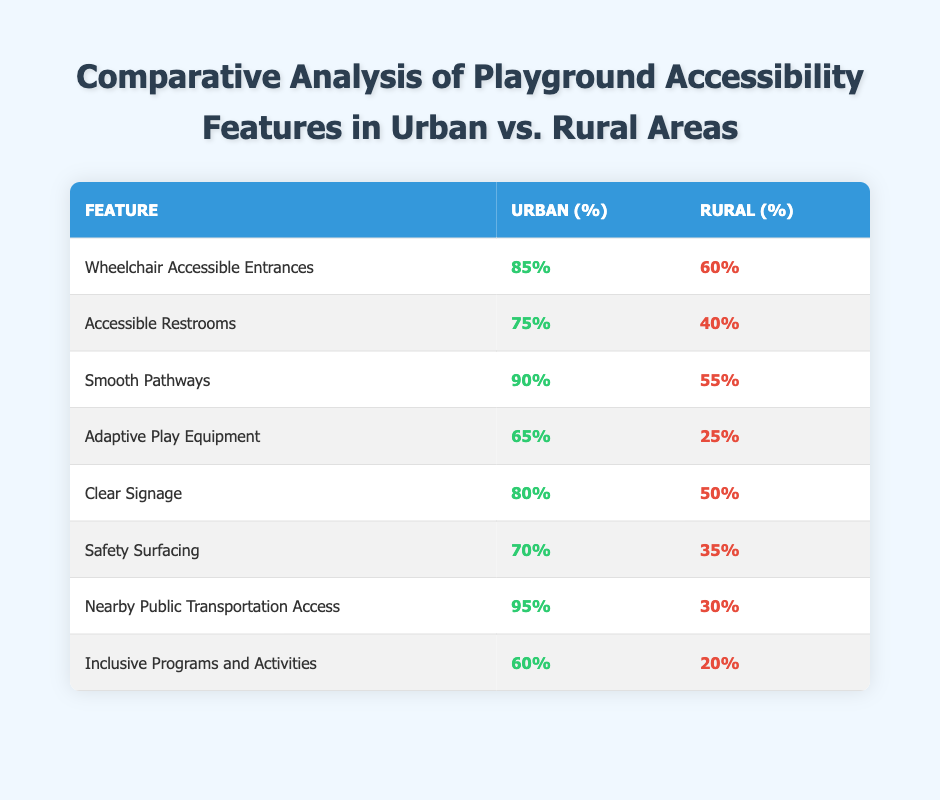What percentage of urban playgrounds have wheelchair accessible entrances? According to the table, the percentage of urban playgrounds with wheelchair accessible entrances is 85%.
Answer: 85% What percentage of rural playgrounds have accessible restrooms? The table shows that 40% of rural playgrounds have accessible restrooms.
Answer: 40% Is the percentage of urban playgrounds with adaptive play equipment higher than that of rural playgrounds? Yes, the table indicates that 65% of urban playgrounds have adaptive play equipment compared to only 25% of rural playgrounds, confirming that urban playgrounds have a higher percentage.
Answer: Yes What is the difference between the percentage of urban and rural playgrounds that provide clear signage? The percentage of urban playgrounds with clear signage is 80%, while rural playgrounds have 50%. The difference is calculated by subtracting the rural percentage from the urban percentage: 80% - 50% = 30%.
Answer: 30% Which feature has the largest gap in accessibility between urban and rural areas? By comparing the values across features in the table, the largest gap is for "Nearby Public Transportation Access," where the urban percentage is 95% and the rural percentage is 30%, resulting in a gap of 65%.
Answer: 65% 